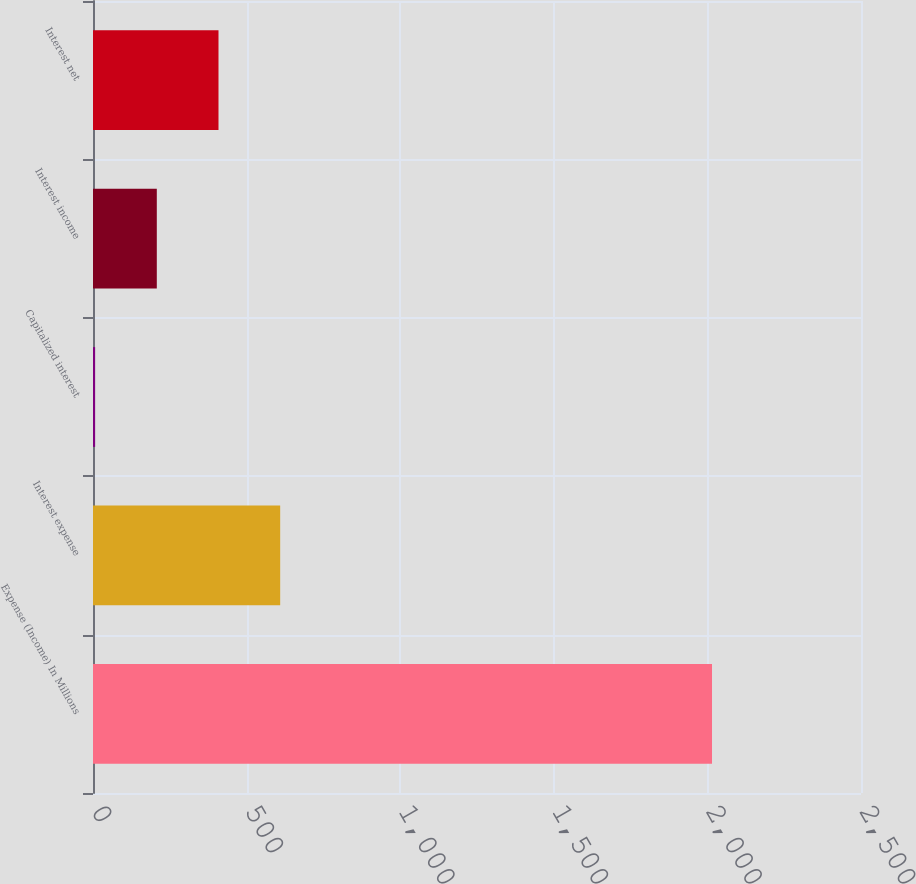<chart> <loc_0><loc_0><loc_500><loc_500><bar_chart><fcel>Expense (Income) In Millions<fcel>Interest expense<fcel>Capitalized interest<fcel>Interest income<fcel>Interest net<nl><fcel>2015<fcel>609.33<fcel>6.9<fcel>207.71<fcel>408.52<nl></chart> 